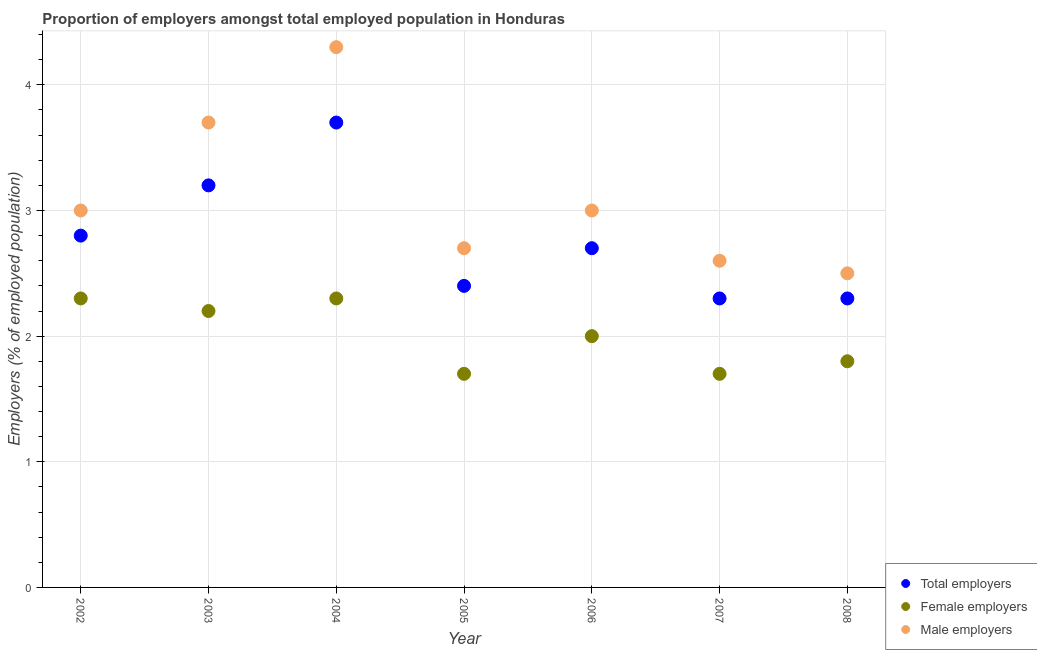How many different coloured dotlines are there?
Offer a very short reply. 3. What is the percentage of male employers in 2005?
Make the answer very short. 2.7. Across all years, what is the maximum percentage of female employers?
Make the answer very short. 2.3. Across all years, what is the minimum percentage of total employers?
Give a very brief answer. 2.3. What is the total percentage of male employers in the graph?
Your response must be concise. 21.8. What is the difference between the percentage of male employers in 2006 and that in 2007?
Make the answer very short. 0.4. What is the difference between the percentage of female employers in 2007 and the percentage of male employers in 2005?
Give a very brief answer. -1. What is the average percentage of total employers per year?
Your response must be concise. 2.77. In the year 2002, what is the difference between the percentage of male employers and percentage of total employers?
Keep it short and to the point. 0.2. In how many years, is the percentage of male employers greater than 4 %?
Offer a very short reply. 1. What is the ratio of the percentage of female employers in 2003 to that in 2006?
Keep it short and to the point. 1.1. Is the percentage of female employers in 2007 less than that in 2008?
Your response must be concise. Yes. What is the difference between the highest and the second highest percentage of female employers?
Offer a terse response. 0. What is the difference between the highest and the lowest percentage of female employers?
Make the answer very short. 0.6. In how many years, is the percentage of male employers greater than the average percentage of male employers taken over all years?
Ensure brevity in your answer.  2. Is the sum of the percentage of male employers in 2006 and 2008 greater than the maximum percentage of female employers across all years?
Give a very brief answer. Yes. Does the percentage of male employers monotonically increase over the years?
Offer a very short reply. No. Is the percentage of male employers strictly less than the percentage of female employers over the years?
Your response must be concise. No. How many dotlines are there?
Keep it short and to the point. 3. How many years are there in the graph?
Give a very brief answer. 7. Does the graph contain any zero values?
Your response must be concise. No. How many legend labels are there?
Your answer should be compact. 3. How are the legend labels stacked?
Your response must be concise. Vertical. What is the title of the graph?
Give a very brief answer. Proportion of employers amongst total employed population in Honduras. What is the label or title of the X-axis?
Offer a very short reply. Year. What is the label or title of the Y-axis?
Make the answer very short. Employers (% of employed population). What is the Employers (% of employed population) of Total employers in 2002?
Offer a very short reply. 2.8. What is the Employers (% of employed population) in Female employers in 2002?
Provide a short and direct response. 2.3. What is the Employers (% of employed population) in Male employers in 2002?
Your answer should be very brief. 3. What is the Employers (% of employed population) of Total employers in 2003?
Your answer should be very brief. 3.2. What is the Employers (% of employed population) in Female employers in 2003?
Provide a short and direct response. 2.2. What is the Employers (% of employed population) of Male employers in 2003?
Give a very brief answer. 3.7. What is the Employers (% of employed population) of Total employers in 2004?
Keep it short and to the point. 3.7. What is the Employers (% of employed population) of Female employers in 2004?
Your response must be concise. 2.3. What is the Employers (% of employed population) of Male employers in 2004?
Keep it short and to the point. 4.3. What is the Employers (% of employed population) of Total employers in 2005?
Offer a very short reply. 2.4. What is the Employers (% of employed population) in Female employers in 2005?
Offer a very short reply. 1.7. What is the Employers (% of employed population) of Male employers in 2005?
Keep it short and to the point. 2.7. What is the Employers (% of employed population) of Total employers in 2006?
Your answer should be compact. 2.7. What is the Employers (% of employed population) in Male employers in 2006?
Your answer should be compact. 3. What is the Employers (% of employed population) of Total employers in 2007?
Make the answer very short. 2.3. What is the Employers (% of employed population) of Female employers in 2007?
Provide a succinct answer. 1.7. What is the Employers (% of employed population) in Male employers in 2007?
Give a very brief answer. 2.6. What is the Employers (% of employed population) in Total employers in 2008?
Ensure brevity in your answer.  2.3. What is the Employers (% of employed population) of Female employers in 2008?
Your response must be concise. 1.8. Across all years, what is the maximum Employers (% of employed population) in Total employers?
Offer a very short reply. 3.7. Across all years, what is the maximum Employers (% of employed population) of Female employers?
Your answer should be very brief. 2.3. Across all years, what is the maximum Employers (% of employed population) in Male employers?
Ensure brevity in your answer.  4.3. Across all years, what is the minimum Employers (% of employed population) of Total employers?
Your answer should be compact. 2.3. Across all years, what is the minimum Employers (% of employed population) of Female employers?
Ensure brevity in your answer.  1.7. Across all years, what is the minimum Employers (% of employed population) in Male employers?
Provide a short and direct response. 2.5. What is the total Employers (% of employed population) in Total employers in the graph?
Offer a terse response. 19.4. What is the total Employers (% of employed population) of Male employers in the graph?
Ensure brevity in your answer.  21.8. What is the difference between the Employers (% of employed population) of Female employers in 2002 and that in 2003?
Provide a succinct answer. 0.1. What is the difference between the Employers (% of employed population) in Female employers in 2002 and that in 2004?
Your response must be concise. 0. What is the difference between the Employers (% of employed population) in Male employers in 2002 and that in 2004?
Provide a succinct answer. -1.3. What is the difference between the Employers (% of employed population) in Male employers in 2002 and that in 2005?
Provide a succinct answer. 0.3. What is the difference between the Employers (% of employed population) in Total employers in 2002 and that in 2006?
Provide a short and direct response. 0.1. What is the difference between the Employers (% of employed population) in Female employers in 2002 and that in 2006?
Your answer should be very brief. 0.3. What is the difference between the Employers (% of employed population) in Total employers in 2002 and that in 2007?
Your answer should be very brief. 0.5. What is the difference between the Employers (% of employed population) of Female employers in 2002 and that in 2007?
Give a very brief answer. 0.6. What is the difference between the Employers (% of employed population) of Female employers in 2002 and that in 2008?
Your response must be concise. 0.5. What is the difference between the Employers (% of employed population) of Total employers in 2003 and that in 2004?
Give a very brief answer. -0.5. What is the difference between the Employers (% of employed population) in Female employers in 2003 and that in 2004?
Ensure brevity in your answer.  -0.1. What is the difference between the Employers (% of employed population) of Male employers in 2003 and that in 2004?
Offer a terse response. -0.6. What is the difference between the Employers (% of employed population) in Female employers in 2003 and that in 2005?
Your answer should be very brief. 0.5. What is the difference between the Employers (% of employed population) of Total employers in 2003 and that in 2007?
Your answer should be very brief. 0.9. What is the difference between the Employers (% of employed population) in Male employers in 2003 and that in 2007?
Your answer should be compact. 1.1. What is the difference between the Employers (% of employed population) of Total employers in 2003 and that in 2008?
Offer a very short reply. 0.9. What is the difference between the Employers (% of employed population) in Total employers in 2004 and that in 2006?
Provide a succinct answer. 1. What is the difference between the Employers (% of employed population) of Male employers in 2004 and that in 2006?
Ensure brevity in your answer.  1.3. What is the difference between the Employers (% of employed population) in Male employers in 2004 and that in 2007?
Offer a terse response. 1.7. What is the difference between the Employers (% of employed population) in Female employers in 2005 and that in 2006?
Offer a terse response. -0.3. What is the difference between the Employers (% of employed population) of Total employers in 2005 and that in 2007?
Your answer should be compact. 0.1. What is the difference between the Employers (% of employed population) of Female employers in 2005 and that in 2007?
Provide a succinct answer. 0. What is the difference between the Employers (% of employed population) in Male employers in 2005 and that in 2007?
Provide a short and direct response. 0.1. What is the difference between the Employers (% of employed population) of Total employers in 2005 and that in 2008?
Offer a very short reply. 0.1. What is the difference between the Employers (% of employed population) in Male employers in 2005 and that in 2008?
Provide a short and direct response. 0.2. What is the difference between the Employers (% of employed population) in Female employers in 2006 and that in 2007?
Make the answer very short. 0.3. What is the difference between the Employers (% of employed population) in Male employers in 2006 and that in 2007?
Your answer should be compact. 0.4. What is the difference between the Employers (% of employed population) of Total employers in 2007 and that in 2008?
Ensure brevity in your answer.  0. What is the difference between the Employers (% of employed population) in Total employers in 2002 and the Employers (% of employed population) in Male employers in 2003?
Your answer should be very brief. -0.9. What is the difference between the Employers (% of employed population) in Female employers in 2002 and the Employers (% of employed population) in Male employers in 2003?
Keep it short and to the point. -1.4. What is the difference between the Employers (% of employed population) in Total employers in 2002 and the Employers (% of employed population) in Male employers in 2004?
Provide a short and direct response. -1.5. What is the difference between the Employers (% of employed population) in Female employers in 2002 and the Employers (% of employed population) in Male employers in 2004?
Offer a terse response. -2. What is the difference between the Employers (% of employed population) of Total employers in 2002 and the Employers (% of employed population) of Female employers in 2005?
Provide a short and direct response. 1.1. What is the difference between the Employers (% of employed population) in Total employers in 2002 and the Employers (% of employed population) in Female employers in 2006?
Give a very brief answer. 0.8. What is the difference between the Employers (% of employed population) in Female employers in 2002 and the Employers (% of employed population) in Male employers in 2006?
Your answer should be very brief. -0.7. What is the difference between the Employers (% of employed population) of Total employers in 2002 and the Employers (% of employed population) of Female employers in 2008?
Keep it short and to the point. 1. What is the difference between the Employers (% of employed population) in Female employers in 2002 and the Employers (% of employed population) in Male employers in 2008?
Provide a succinct answer. -0.2. What is the difference between the Employers (% of employed population) of Total employers in 2003 and the Employers (% of employed population) of Female employers in 2005?
Offer a very short reply. 1.5. What is the difference between the Employers (% of employed population) in Total employers in 2003 and the Employers (% of employed population) in Male employers in 2005?
Offer a terse response. 0.5. What is the difference between the Employers (% of employed population) in Total employers in 2003 and the Employers (% of employed population) in Female employers in 2006?
Your response must be concise. 1.2. What is the difference between the Employers (% of employed population) of Female employers in 2003 and the Employers (% of employed population) of Male employers in 2008?
Offer a terse response. -0.3. What is the difference between the Employers (% of employed population) in Total employers in 2004 and the Employers (% of employed population) in Female employers in 2005?
Provide a short and direct response. 2. What is the difference between the Employers (% of employed population) in Total employers in 2004 and the Employers (% of employed population) in Male employers in 2005?
Your answer should be very brief. 1. What is the difference between the Employers (% of employed population) of Total employers in 2004 and the Employers (% of employed population) of Female employers in 2006?
Keep it short and to the point. 1.7. What is the difference between the Employers (% of employed population) in Total employers in 2004 and the Employers (% of employed population) in Male employers in 2006?
Your answer should be compact. 0.7. What is the difference between the Employers (% of employed population) in Female employers in 2004 and the Employers (% of employed population) in Male employers in 2007?
Your response must be concise. -0.3. What is the difference between the Employers (% of employed population) of Female employers in 2005 and the Employers (% of employed population) of Male employers in 2006?
Keep it short and to the point. -1.3. What is the difference between the Employers (% of employed population) in Total employers in 2005 and the Employers (% of employed population) in Female employers in 2007?
Keep it short and to the point. 0.7. What is the difference between the Employers (% of employed population) in Female employers in 2005 and the Employers (% of employed population) in Male employers in 2007?
Provide a succinct answer. -0.9. What is the difference between the Employers (% of employed population) in Total employers in 2005 and the Employers (% of employed population) in Female employers in 2008?
Your response must be concise. 0.6. What is the difference between the Employers (% of employed population) in Total employers in 2005 and the Employers (% of employed population) in Male employers in 2008?
Your response must be concise. -0.1. What is the difference between the Employers (% of employed population) of Female employers in 2005 and the Employers (% of employed population) of Male employers in 2008?
Offer a terse response. -0.8. What is the difference between the Employers (% of employed population) in Total employers in 2006 and the Employers (% of employed population) in Female employers in 2007?
Offer a very short reply. 1. What is the difference between the Employers (% of employed population) in Total employers in 2006 and the Employers (% of employed population) in Male employers in 2007?
Your answer should be compact. 0.1. What is the difference between the Employers (% of employed population) of Female employers in 2006 and the Employers (% of employed population) of Male employers in 2007?
Make the answer very short. -0.6. What is the difference between the Employers (% of employed population) in Total employers in 2006 and the Employers (% of employed population) in Male employers in 2008?
Your response must be concise. 0.2. What is the difference between the Employers (% of employed population) in Female employers in 2006 and the Employers (% of employed population) in Male employers in 2008?
Offer a terse response. -0.5. What is the difference between the Employers (% of employed population) of Total employers in 2007 and the Employers (% of employed population) of Female employers in 2008?
Provide a short and direct response. 0.5. What is the average Employers (% of employed population) in Total employers per year?
Your answer should be very brief. 2.77. What is the average Employers (% of employed population) of Male employers per year?
Offer a terse response. 3.11. In the year 2003, what is the difference between the Employers (% of employed population) in Total employers and Employers (% of employed population) in Female employers?
Make the answer very short. 1. In the year 2003, what is the difference between the Employers (% of employed population) of Total employers and Employers (% of employed population) of Male employers?
Keep it short and to the point. -0.5. In the year 2003, what is the difference between the Employers (% of employed population) of Female employers and Employers (% of employed population) of Male employers?
Ensure brevity in your answer.  -1.5. In the year 2004, what is the difference between the Employers (% of employed population) in Total employers and Employers (% of employed population) in Male employers?
Give a very brief answer. -0.6. In the year 2004, what is the difference between the Employers (% of employed population) of Female employers and Employers (% of employed population) of Male employers?
Offer a terse response. -2. In the year 2005, what is the difference between the Employers (% of employed population) of Total employers and Employers (% of employed population) of Female employers?
Keep it short and to the point. 0.7. In the year 2006, what is the difference between the Employers (% of employed population) in Female employers and Employers (% of employed population) in Male employers?
Your answer should be compact. -1. In the year 2007, what is the difference between the Employers (% of employed population) in Female employers and Employers (% of employed population) in Male employers?
Give a very brief answer. -0.9. In the year 2008, what is the difference between the Employers (% of employed population) in Total employers and Employers (% of employed population) in Male employers?
Make the answer very short. -0.2. In the year 2008, what is the difference between the Employers (% of employed population) of Female employers and Employers (% of employed population) of Male employers?
Your response must be concise. -0.7. What is the ratio of the Employers (% of employed population) of Total employers in 2002 to that in 2003?
Your response must be concise. 0.88. What is the ratio of the Employers (% of employed population) in Female employers in 2002 to that in 2003?
Offer a very short reply. 1.05. What is the ratio of the Employers (% of employed population) of Male employers in 2002 to that in 2003?
Your response must be concise. 0.81. What is the ratio of the Employers (% of employed population) in Total employers in 2002 to that in 2004?
Make the answer very short. 0.76. What is the ratio of the Employers (% of employed population) in Male employers in 2002 to that in 2004?
Provide a short and direct response. 0.7. What is the ratio of the Employers (% of employed population) of Total employers in 2002 to that in 2005?
Your answer should be compact. 1.17. What is the ratio of the Employers (% of employed population) in Female employers in 2002 to that in 2005?
Make the answer very short. 1.35. What is the ratio of the Employers (% of employed population) in Female employers in 2002 to that in 2006?
Provide a succinct answer. 1.15. What is the ratio of the Employers (% of employed population) of Male employers in 2002 to that in 2006?
Provide a succinct answer. 1. What is the ratio of the Employers (% of employed population) of Total employers in 2002 to that in 2007?
Make the answer very short. 1.22. What is the ratio of the Employers (% of employed population) of Female employers in 2002 to that in 2007?
Provide a succinct answer. 1.35. What is the ratio of the Employers (% of employed population) in Male employers in 2002 to that in 2007?
Make the answer very short. 1.15. What is the ratio of the Employers (% of employed population) of Total employers in 2002 to that in 2008?
Make the answer very short. 1.22. What is the ratio of the Employers (% of employed population) of Female employers in 2002 to that in 2008?
Provide a succinct answer. 1.28. What is the ratio of the Employers (% of employed population) of Total employers in 2003 to that in 2004?
Keep it short and to the point. 0.86. What is the ratio of the Employers (% of employed population) in Female employers in 2003 to that in 2004?
Your answer should be compact. 0.96. What is the ratio of the Employers (% of employed population) in Male employers in 2003 to that in 2004?
Your answer should be compact. 0.86. What is the ratio of the Employers (% of employed population) in Total employers in 2003 to that in 2005?
Your answer should be very brief. 1.33. What is the ratio of the Employers (% of employed population) in Female employers in 2003 to that in 2005?
Offer a terse response. 1.29. What is the ratio of the Employers (% of employed population) in Male employers in 2003 to that in 2005?
Offer a terse response. 1.37. What is the ratio of the Employers (% of employed population) of Total employers in 2003 to that in 2006?
Give a very brief answer. 1.19. What is the ratio of the Employers (% of employed population) of Female employers in 2003 to that in 2006?
Your answer should be compact. 1.1. What is the ratio of the Employers (% of employed population) of Male employers in 2003 to that in 2006?
Provide a short and direct response. 1.23. What is the ratio of the Employers (% of employed population) in Total employers in 2003 to that in 2007?
Your answer should be very brief. 1.39. What is the ratio of the Employers (% of employed population) of Female employers in 2003 to that in 2007?
Ensure brevity in your answer.  1.29. What is the ratio of the Employers (% of employed population) of Male employers in 2003 to that in 2007?
Ensure brevity in your answer.  1.42. What is the ratio of the Employers (% of employed population) in Total employers in 2003 to that in 2008?
Make the answer very short. 1.39. What is the ratio of the Employers (% of employed population) of Female employers in 2003 to that in 2008?
Make the answer very short. 1.22. What is the ratio of the Employers (% of employed population) in Male employers in 2003 to that in 2008?
Give a very brief answer. 1.48. What is the ratio of the Employers (% of employed population) in Total employers in 2004 to that in 2005?
Ensure brevity in your answer.  1.54. What is the ratio of the Employers (% of employed population) in Female employers in 2004 to that in 2005?
Your answer should be compact. 1.35. What is the ratio of the Employers (% of employed population) of Male employers in 2004 to that in 2005?
Ensure brevity in your answer.  1.59. What is the ratio of the Employers (% of employed population) in Total employers in 2004 to that in 2006?
Provide a succinct answer. 1.37. What is the ratio of the Employers (% of employed population) in Female employers in 2004 to that in 2006?
Offer a terse response. 1.15. What is the ratio of the Employers (% of employed population) of Male employers in 2004 to that in 2006?
Make the answer very short. 1.43. What is the ratio of the Employers (% of employed population) of Total employers in 2004 to that in 2007?
Give a very brief answer. 1.61. What is the ratio of the Employers (% of employed population) of Female employers in 2004 to that in 2007?
Offer a very short reply. 1.35. What is the ratio of the Employers (% of employed population) of Male employers in 2004 to that in 2007?
Provide a short and direct response. 1.65. What is the ratio of the Employers (% of employed population) of Total employers in 2004 to that in 2008?
Your response must be concise. 1.61. What is the ratio of the Employers (% of employed population) in Female employers in 2004 to that in 2008?
Your response must be concise. 1.28. What is the ratio of the Employers (% of employed population) of Male employers in 2004 to that in 2008?
Make the answer very short. 1.72. What is the ratio of the Employers (% of employed population) in Female employers in 2005 to that in 2006?
Offer a terse response. 0.85. What is the ratio of the Employers (% of employed population) of Total employers in 2005 to that in 2007?
Provide a succinct answer. 1.04. What is the ratio of the Employers (% of employed population) in Female employers in 2005 to that in 2007?
Offer a very short reply. 1. What is the ratio of the Employers (% of employed population) in Male employers in 2005 to that in 2007?
Ensure brevity in your answer.  1.04. What is the ratio of the Employers (% of employed population) in Total employers in 2005 to that in 2008?
Provide a succinct answer. 1.04. What is the ratio of the Employers (% of employed population) of Female employers in 2005 to that in 2008?
Keep it short and to the point. 0.94. What is the ratio of the Employers (% of employed population) in Total employers in 2006 to that in 2007?
Give a very brief answer. 1.17. What is the ratio of the Employers (% of employed population) in Female employers in 2006 to that in 2007?
Provide a short and direct response. 1.18. What is the ratio of the Employers (% of employed population) in Male employers in 2006 to that in 2007?
Your response must be concise. 1.15. What is the ratio of the Employers (% of employed population) in Total employers in 2006 to that in 2008?
Your response must be concise. 1.17. What is the ratio of the Employers (% of employed population) in Female employers in 2006 to that in 2008?
Your answer should be very brief. 1.11. What is the ratio of the Employers (% of employed population) in Male employers in 2006 to that in 2008?
Keep it short and to the point. 1.2. What is the ratio of the Employers (% of employed population) of Female employers in 2007 to that in 2008?
Provide a succinct answer. 0.94. What is the ratio of the Employers (% of employed population) of Male employers in 2007 to that in 2008?
Ensure brevity in your answer.  1.04. What is the difference between the highest and the second highest Employers (% of employed population) of Female employers?
Make the answer very short. 0. What is the difference between the highest and the lowest Employers (% of employed population) in Total employers?
Offer a very short reply. 1.4. What is the difference between the highest and the lowest Employers (% of employed population) in Female employers?
Provide a short and direct response. 0.6. What is the difference between the highest and the lowest Employers (% of employed population) of Male employers?
Provide a short and direct response. 1.8. 